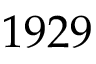Convert formula to latex. <formula><loc_0><loc_0><loc_500><loc_500>1 9 2 9</formula> 